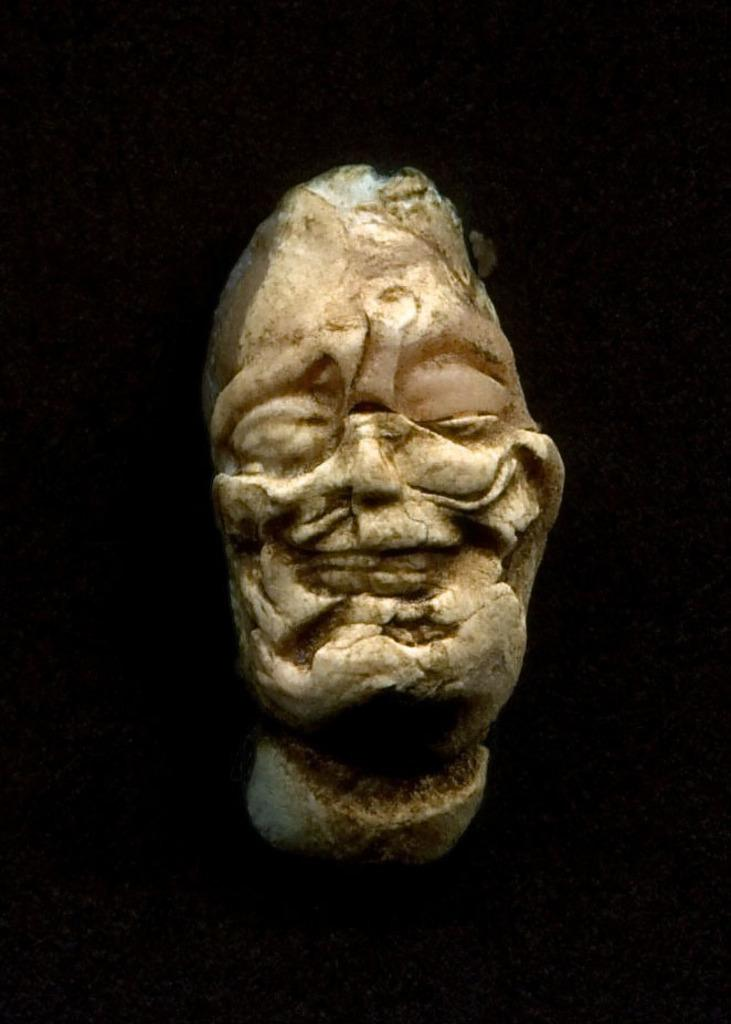What is the main subject of the image? There is a sculpture in the middle of the image. What color is the background of the image? The background of the image is black in color. How many passengers are visible in the image? There are no passengers present in the image; it features a sculpture with a black background. What type of drum can be heard playing in the image? There is no drum or sound present in the image; it is a still image of a sculpture with a black background. 